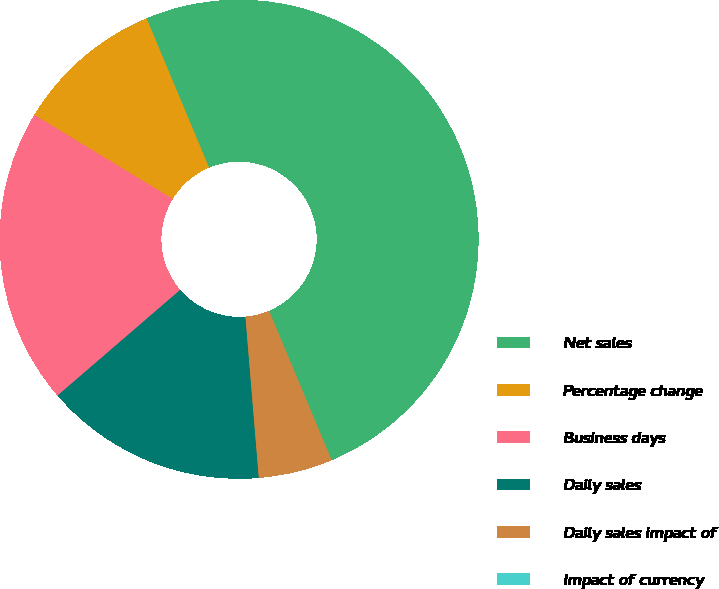<chart> <loc_0><loc_0><loc_500><loc_500><pie_chart><fcel>Net sales<fcel>Percentage change<fcel>Business days<fcel>Daily sales<fcel>Daily sales impact of<fcel>Impact of currency<nl><fcel>50.0%<fcel>10.0%<fcel>20.0%<fcel>15.0%<fcel>5.0%<fcel>0.0%<nl></chart> 